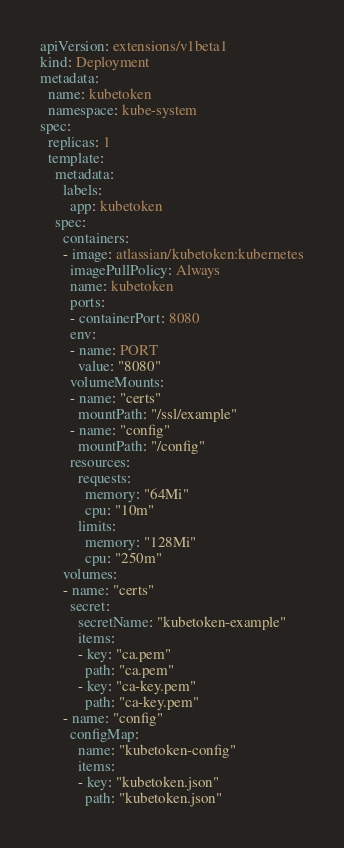<code> <loc_0><loc_0><loc_500><loc_500><_YAML_>apiVersion: extensions/v1beta1
kind: Deployment
metadata:
  name: kubetoken
  namespace: kube-system
spec:
  replicas: 1
  template:
    metadata:
      labels:
        app: kubetoken
    spec:
      containers:
      - image: atlassian/kubetoken:kubernetes
        imagePullPolicy: Always
        name: kubetoken
        ports:
        - containerPort: 8080
        env:
        - name: PORT
          value: "8080"
        volumeMounts:
        - name: "certs"
          mountPath: "/ssl/example"
        - name: "config"
          mountPath: "/config"
        resources:
          requests:
            memory: "64Mi"
            cpu: "10m"
          limits:
            memory: "128Mi"
            cpu: "250m"
      volumes:
      - name: "certs"
        secret:
          secretName: "kubetoken-example"
          items:
          - key: "ca.pem"
            path: "ca.pem"
          - key: "ca-key.pem"
            path: "ca-key.pem"
      - name: "config"
        configMap:
          name: "kubetoken-config"
          items:
          - key: "kubetoken.json"
            path: "kubetoken.json"
</code> 